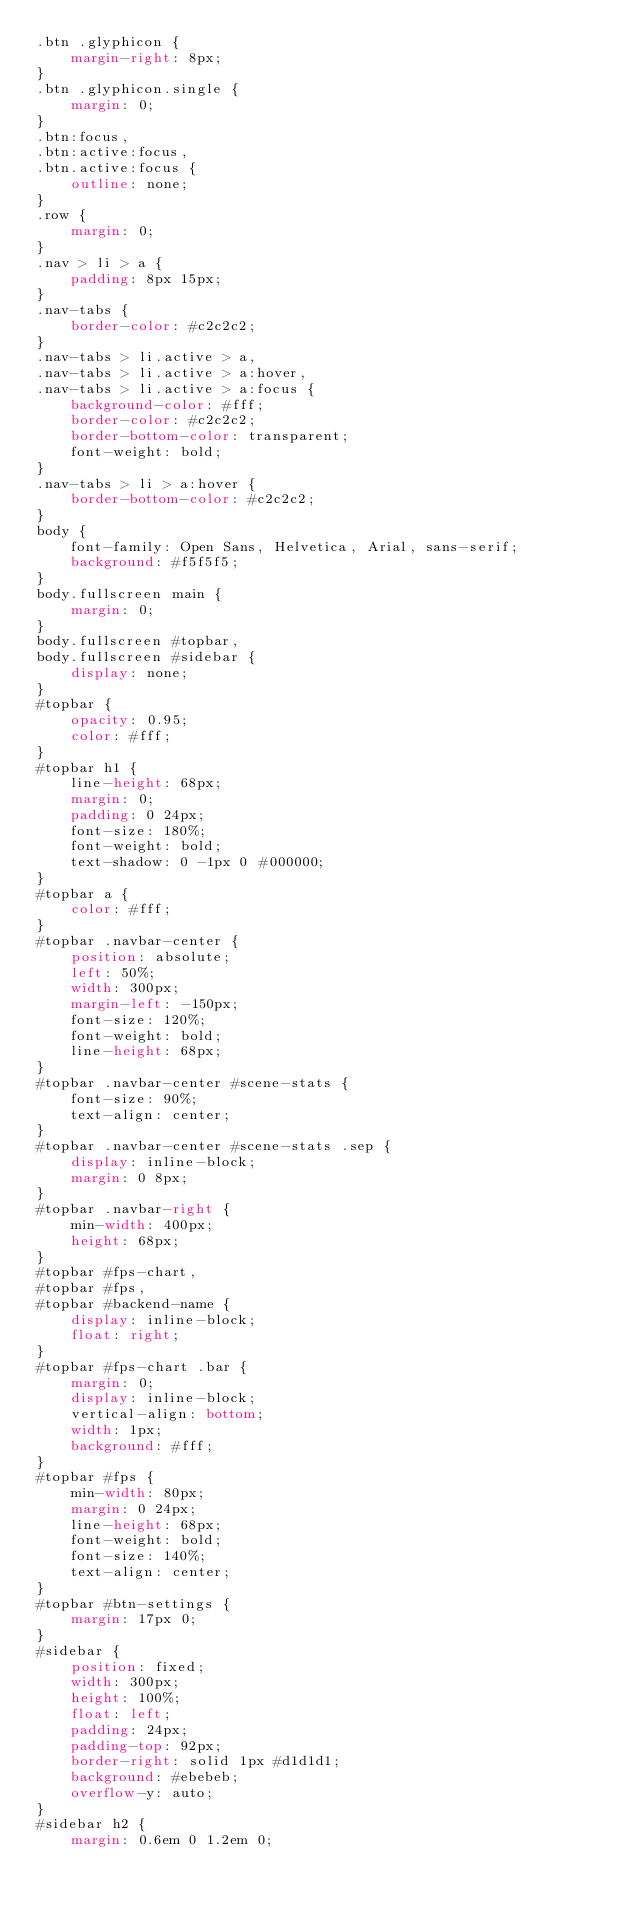<code> <loc_0><loc_0><loc_500><loc_500><_CSS_>.btn .glyphicon {
    margin-right: 8px;
}
.btn .glyphicon.single {
    margin: 0;
}
.btn:focus,
.btn:active:focus,
.btn.active:focus {
    outline: none;
}
.row {
    margin: 0;
}
.nav > li > a {
    padding: 8px 15px;
}
.nav-tabs {
    border-color: #c2c2c2;
}
.nav-tabs > li.active > a,
.nav-tabs > li.active > a:hover,
.nav-tabs > li.active > a:focus {
    background-color: #fff;
    border-color: #c2c2c2;
    border-bottom-color: transparent;
    font-weight: bold;
}
.nav-tabs > li > a:hover {
    border-bottom-color: #c2c2c2;
}
body {
    font-family: Open Sans, Helvetica, Arial, sans-serif;
    background: #f5f5f5;
}
body.fullscreen main {
    margin: 0;
}
body.fullscreen #topbar,
body.fullscreen #sidebar {
    display: none;
}
#topbar {
    opacity: 0.95;
    color: #fff;
}
#topbar h1 {
    line-height: 68px;
    margin: 0;
    padding: 0 24px;
    font-size: 180%;
    font-weight: bold;
    text-shadow: 0 -1px 0 #000000;
}
#topbar a {
    color: #fff;
}
#topbar .navbar-center {
    position: absolute;
    left: 50%;
    width: 300px;
    margin-left: -150px;
    font-size: 120%;
    font-weight: bold;
    line-height: 68px;
}
#topbar .navbar-center #scene-stats {
    font-size: 90%;
    text-align: center;
}
#topbar .navbar-center #scene-stats .sep {
    display: inline-block;
    margin: 0 8px;
}
#topbar .navbar-right {
    min-width: 400px;
    height: 68px;
}
#topbar #fps-chart,
#topbar #fps,
#topbar #backend-name {
    display: inline-block;
    float: right;
}
#topbar #fps-chart .bar {
    margin: 0;
    display: inline-block;
    vertical-align: bottom;
    width: 1px;
    background: #fff;
}
#topbar #fps {
    min-width: 80px;
    margin: 0 24px;
    line-height: 68px;
    font-weight: bold;
    font-size: 140%;
    text-align: center;
}
#topbar #btn-settings {
    margin: 17px 0;
}
#sidebar {
    position: fixed;
    width: 300px;
    height: 100%;
    float: left;
    padding: 24px;
    padding-top: 92px;
    border-right: solid 1px #d1d1d1;
    background: #ebebeb;
    overflow-y: auto;
}
#sidebar h2 {
    margin: 0.6em 0 1.2em 0;</code> 